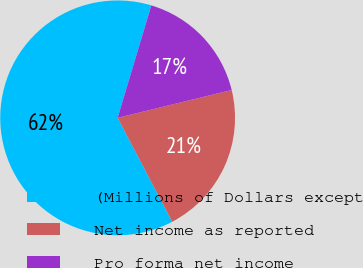Convert chart to OTSL. <chart><loc_0><loc_0><loc_500><loc_500><pie_chart><fcel>(Millions of Dollars except<fcel>Net income as reported<fcel>Pro forma net income<nl><fcel>62.33%<fcel>21.12%<fcel>16.55%<nl></chart> 